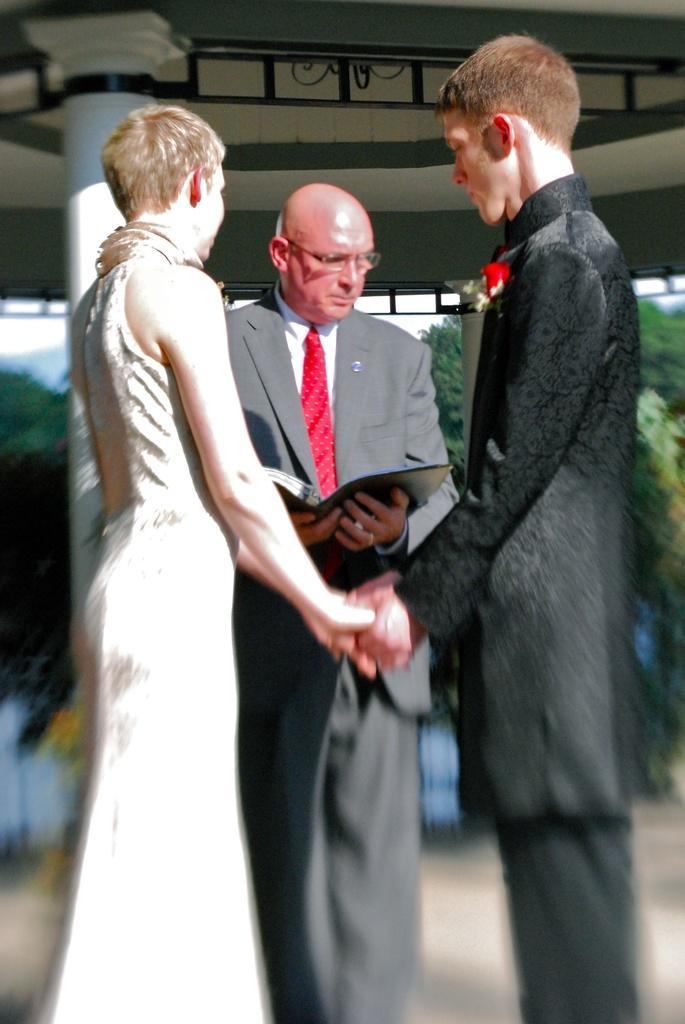Can you describe this image briefly? In this picture there are two persons standing and holding hands of each other and there is another person standing and holding a book in his hand and there are trees in the background. 